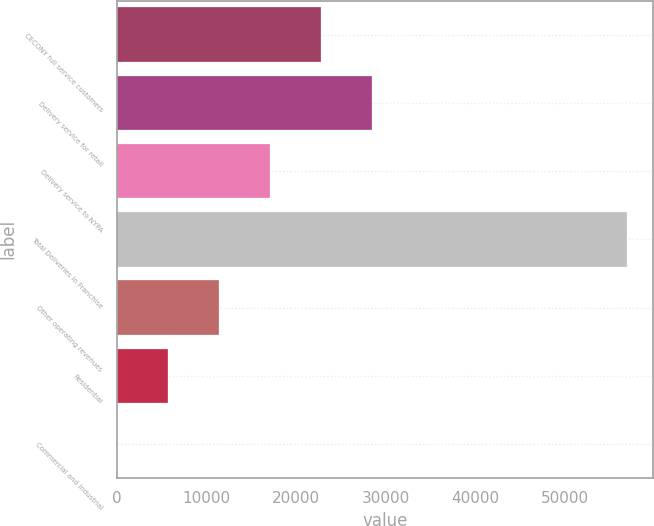Convert chart to OTSL. <chart><loc_0><loc_0><loc_500><loc_500><bar_chart><fcel>CECONY full service customers<fcel>Delivery service for retail<fcel>Delivery service to NYPA<fcel>Total Deliveries in Franchise<fcel>Other operating revenues<fcel>Residential<fcel>Commercial and Industrial<nl><fcel>22779.6<fcel>28469.3<fcel>17089.8<fcel>56918<fcel>11400.1<fcel>5710.34<fcel>20.6<nl></chart> 